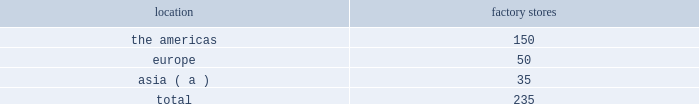We operated the following factory stores as of march 29 , 2014: .
( a ) includes australia , china , hong kong , japan , malaysia , south korea , and taiwan .
Our factory stores in the americas offer selections of our menswear , womenswear , childrenswear , accessories , home furnishings , and fragrances .
Ranging in size from approximately 2700 to 20000 square feet , with an average of approximately 10400 square feet , these stores are principally located in major outlet centers in 40 states in the u.s. , canada , and puerto rico .
Our factory stores in europe offer selections of our menswear , womenswear , childrenswear , accessories , home furnishings , and fragrances .
Ranging in size from approximately 1400 to 19700 square feet , with an average of approximately 7000 square feet , these stores are located in 12 countries , principally in major outlet centers .
Our factory stores in asia offer selections of our menswear , womenswear , childrenswear , accessories , and fragrances .
Ranging in size from approximately 1100 to 11800 square feet , with an average of approximately 6200 square feet , these stores are primarily located throughout china and japan , in hong kong , and in or near other major cities in asia and australia .
Our factory stores are principally located in major outlet centers .
Factory stores obtain products from our suppliers , our product licensing partners , and our other retail stores and e-commerce operations , and also serve as a secondary distribution channel for our excess and out-of-season products .
Concession-based shop-within-shops the terms of trade for shop-within-shops are largely conducted on a concession basis , whereby inventory continues to be owned by us ( not the department store ) until ultimate sale to the end consumer .
The salespeople involved in the sales transactions are generally our employees and not those of the department store .
As of march 29 , 2014 , we had 503 concession-based shop-within-shops at 243 retail locations dedicated to our products , which were located in asia , australia , new zealand , and europe .
The size of our concession-based shop-within-shops ranges from approximately 140 to 7400 square feet .
We may share in the cost of building-out certain of these shop-within-shops with our department store partners .
E-commerce websites in addition to our stores , our retail segment sells products online through our e-commerce channel , which includes : 2022 our north american e-commerce sites located at www.ralphlauren.com and www.clubmonaco.com , as well as our club monaco site in canada located at www.clubmonaco.ca ; 2022 our ralph lauren e-commerce sites in europe , including www.ralphlauren.co.uk ( servicing the united kingdom ) , www.ralphlauren.fr ( servicing belgium , france , italy , luxembourg , the netherlands , portugal , and spain ) , and www.ralphlauren.de ( servicing germany and austria ) ; and 2022 our ralph lauren e-commerce sites in asia , including www.ralphlauren.co.jp servicing japan and www.ralphlauren.co.kr servicing south korea .
Our ralph lauren e-commerce sites in the u.s. , europe , and asia offer our customers access to a broad array of ralph lauren , rrl , polo , and denim & supply apparel , accessories , fragrance , and home products , and reinforce the luxury image of our brands .
While investing in e-commerce operations remains a primary focus , it is an extension of our investment in the integrated omni-channel strategy used to operate our overall retail business , in which our e-commerce operations are interdependent with our physical stores .
Our club monaco e-commerce sites in the u.s .
And canada offer our domestic and canadian customers access to our club monaco global assortment of womenswear , menswear , and accessories product lines , as well as select online exclusives. .
What percentage of factory stores as of march 29 , 2014 are in asia? 
Computations: (35 / 235)
Answer: 0.14894. 